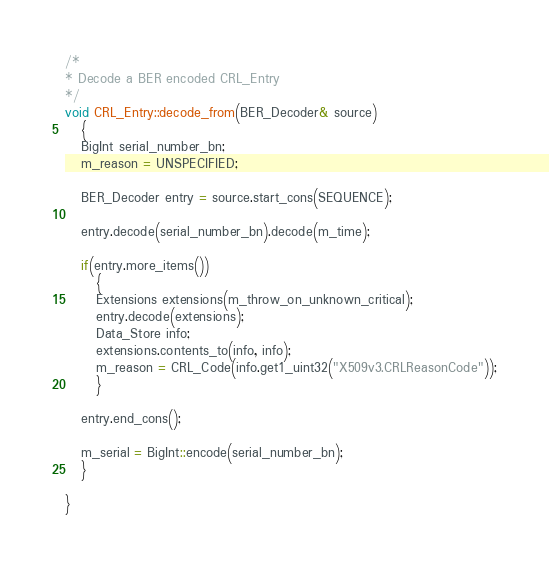<code> <loc_0><loc_0><loc_500><loc_500><_C++_>
/*
* Decode a BER encoded CRL_Entry
*/
void CRL_Entry::decode_from(BER_Decoder& source)
   {
   BigInt serial_number_bn;
   m_reason = UNSPECIFIED;

   BER_Decoder entry = source.start_cons(SEQUENCE);

   entry.decode(serial_number_bn).decode(m_time);

   if(entry.more_items())
      {
      Extensions extensions(m_throw_on_unknown_critical);
      entry.decode(extensions);
      Data_Store info;
      extensions.contents_to(info, info);
      m_reason = CRL_Code(info.get1_uint32("X509v3.CRLReasonCode"));
      }

   entry.end_cons();

   m_serial = BigInt::encode(serial_number_bn);
   }

}
</code> 